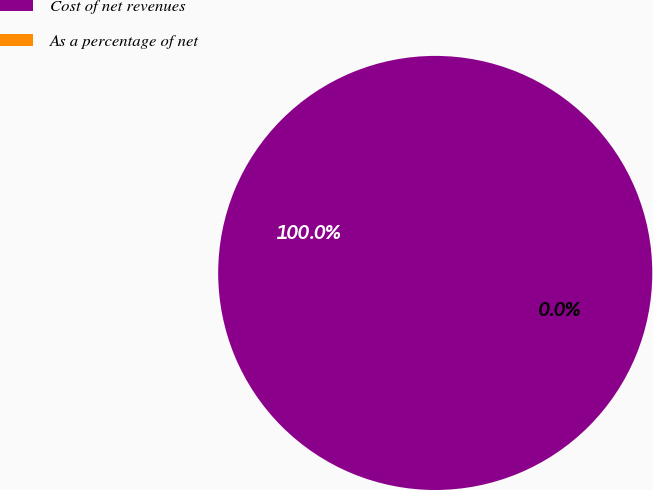Convert chart to OTSL. <chart><loc_0><loc_0><loc_500><loc_500><pie_chart><fcel>Cost of net revenues<fcel>As a percentage of net<nl><fcel>100.0%<fcel>0.0%<nl></chart> 